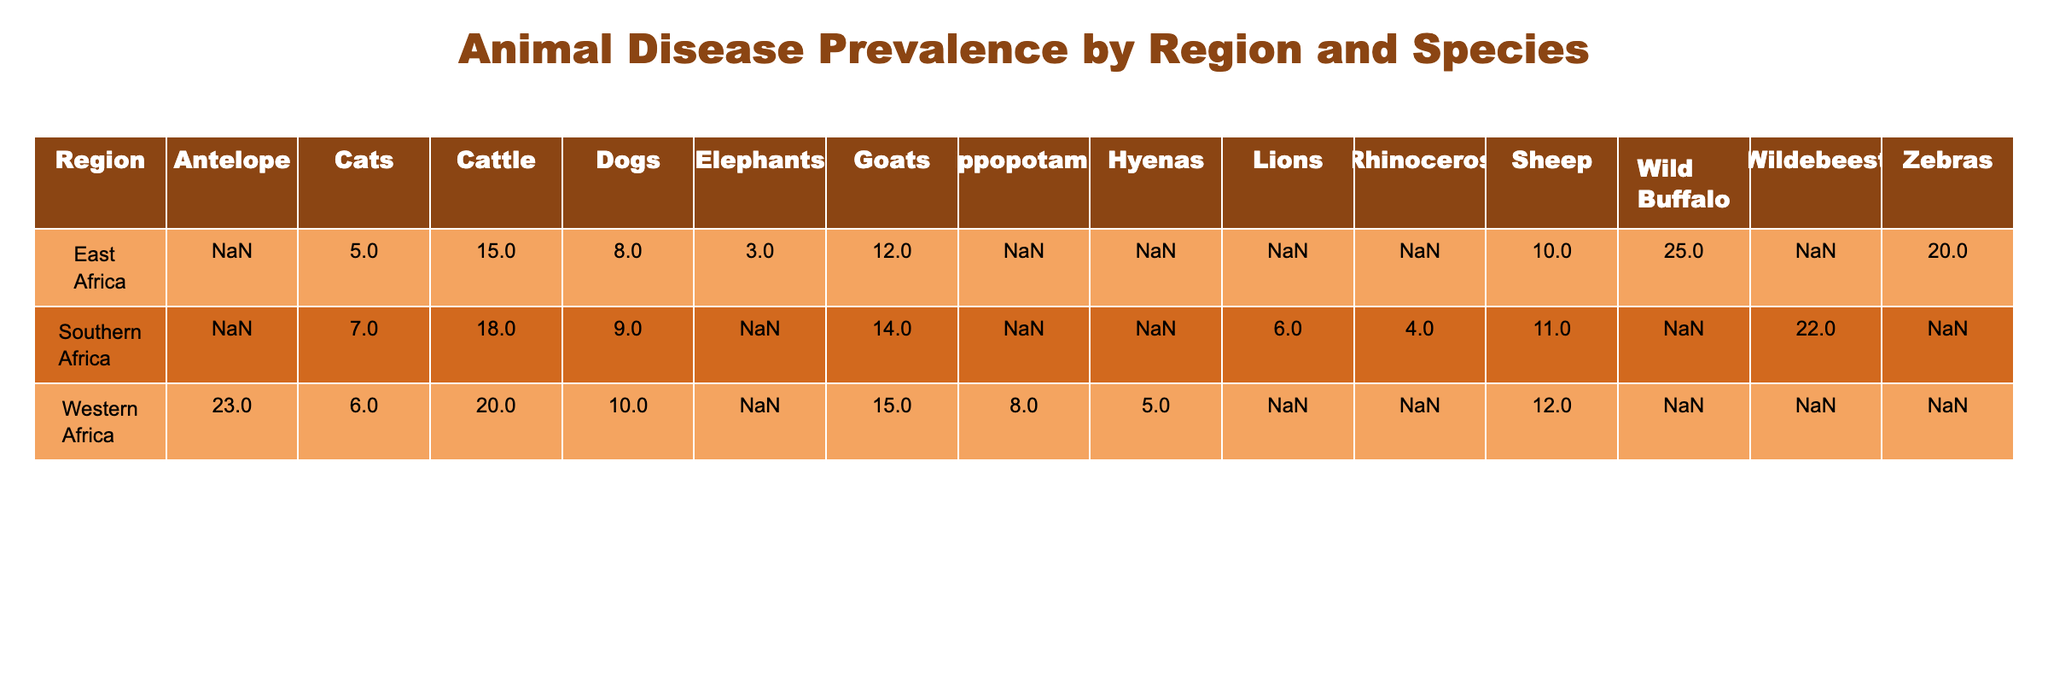What is the disease prevalence percentage for cattle in East Africa? The table shows the disease prevalence percentage for cattle in East Africa as the specific row for East Africa under the Cattle column. According to the table, this value is 15 percent.
Answer: 15% Which species has the highest disease prevalence in Southern Africa? To find the species with the highest disease prevalence in Southern Africa, look at all the species listed under Southern Africa and identify the one with the highest percentage. The values for Southern Africa are: Cattle 18, Goats 14, Sheep 11, Dogs 9, Cats 7, Wildebeest 22, Lions 6, Rhinoceros 4. The highest value is 22 for Wildebeest.
Answer: Wildebeest Is the disease prevalence for dogs in Western Africa higher than in East Africa? The disease prevalence for dogs in Western Africa is 10 percent, while in East Africa it is 8 percent. Since 10 is greater than 8, the statement is true.
Answer: Yes What is the average disease prevalence across all species in Eastern Africa? To find the average, we add the disease prevalence values for all the species in East Africa: Cattle 15 + Goats 12 + Sheep 10 + Dogs 8 + Cats 5 + Zebras 20 + Wild Buffalo 25 + Elephants 3 = 93. There are 8 species, so the average is 93/8 = 11.625.
Answer: 11.625% How many species have a disease prevalence of more than 15% in Western Africa? In Western Africa, the disease prevalence percentages are: Cattle 20, Goats 15, Sheep 12, Dogs 10, Cats 6, Antelope 23, Hippopotamus 8, Hyenas 5. The species with prevalence above 15% are Cattle (20) and Antelope (23), making a total of 2 species.
Answer: 2 Which region has the highest average disease prevalence? To determine the region with the highest average disease prevalence, we calculate the average for each region. For East Africa: (15 + 12 + 10 + 8 + 5 + 20 + 25 + 3) / 8 = 11.625. For Southern Africa: (18 + 14 + 11 + 9 + 7 + 22 + 6 + 4) / 8 = 12.875. For Western Africa: (20 + 15 + 12 + 10 + 6 + 23 + 8 + 5) / 8 = 12.875. Both Southern and Western Africa have the highest average of 12.875.
Answer: Southern Africa, Western Africa 